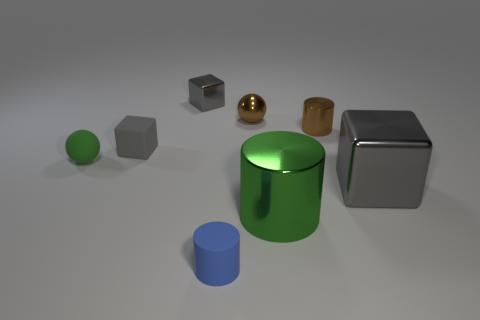What is the shape of the blue matte object?
Give a very brief answer. Cylinder. What number of big rubber cylinders have the same color as the large block?
Your response must be concise. 0. There is another rubber thing that is the same shape as the big gray object; what color is it?
Offer a very short reply. Gray. How many big green cylinders are left of the sphere that is behind the small gray matte object?
Your answer should be compact. 0. How many blocks are gray rubber objects or large green metal things?
Provide a succinct answer. 1. Are any tiny cyan things visible?
Offer a terse response. No. What size is the other matte object that is the same shape as the big green thing?
Provide a succinct answer. Small. There is a gray object that is to the right of the block that is behind the small matte block; what shape is it?
Your response must be concise. Cube. What number of purple things are large balls or rubber cubes?
Provide a short and direct response. 0. The large metal cylinder has what color?
Provide a succinct answer. Green. 